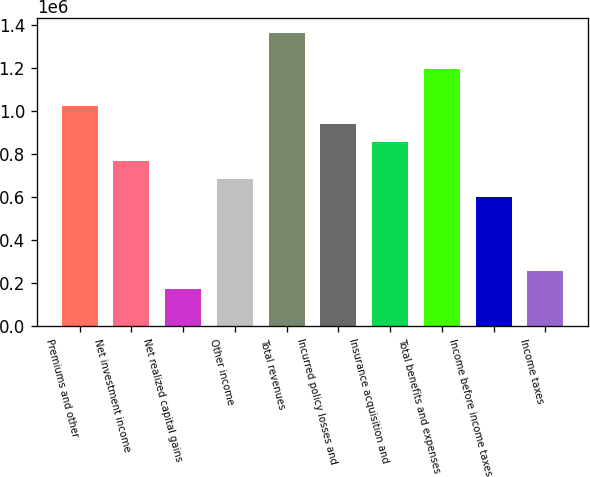<chart> <loc_0><loc_0><loc_500><loc_500><bar_chart><fcel>Premiums and other<fcel>Net investment income<fcel>Net realized capital gains<fcel>Other income<fcel>Total revenues<fcel>Incurred policy losses and<fcel>Insurance acquisition and<fcel>Total benefits and expenses<fcel>Income before income taxes<fcel>Income taxes<nl><fcel>1.02366e+06<fcel>767743<fcel>170610<fcel>682439<fcel>1.36488e+06<fcel>938353<fcel>853048<fcel>1.19427e+06<fcel>597134<fcel>255915<nl></chart> 